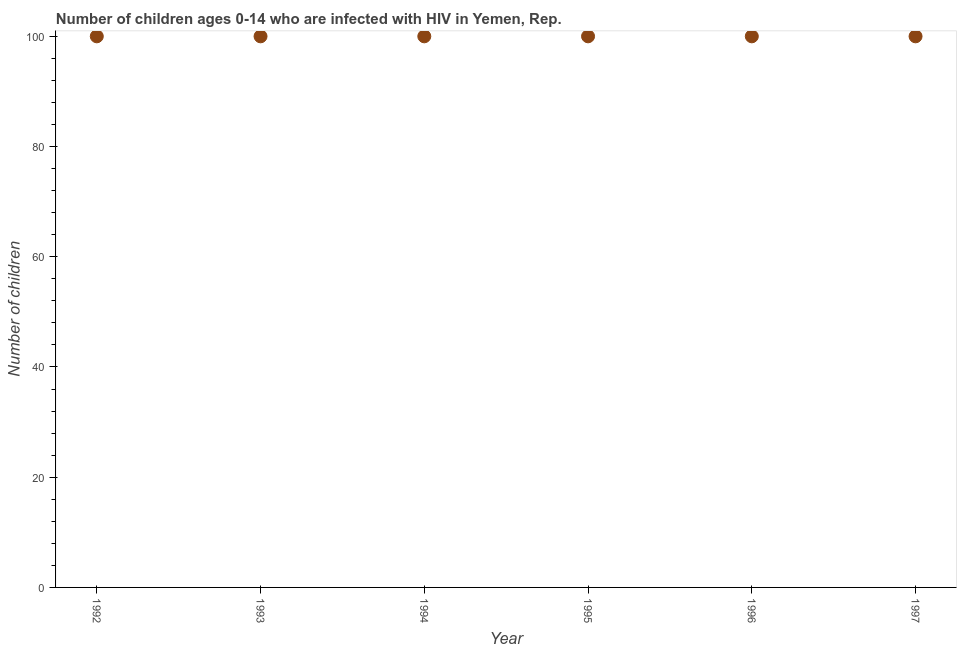What is the number of children living with hiv in 1996?
Your response must be concise. 100. Across all years, what is the maximum number of children living with hiv?
Make the answer very short. 100. Across all years, what is the minimum number of children living with hiv?
Provide a short and direct response. 100. In which year was the number of children living with hiv maximum?
Your response must be concise. 1992. In which year was the number of children living with hiv minimum?
Your answer should be compact. 1992. What is the sum of the number of children living with hiv?
Your answer should be very brief. 600. What is the average number of children living with hiv per year?
Provide a succinct answer. 100. In how many years, is the number of children living with hiv greater than 28 ?
Your answer should be very brief. 6. What is the difference between the highest and the second highest number of children living with hiv?
Your answer should be compact. 0. What is the difference between the highest and the lowest number of children living with hiv?
Your answer should be compact. 0. In how many years, is the number of children living with hiv greater than the average number of children living with hiv taken over all years?
Your response must be concise. 0. How many years are there in the graph?
Your answer should be compact. 6. What is the difference between two consecutive major ticks on the Y-axis?
Make the answer very short. 20. What is the title of the graph?
Ensure brevity in your answer.  Number of children ages 0-14 who are infected with HIV in Yemen, Rep. What is the label or title of the X-axis?
Ensure brevity in your answer.  Year. What is the label or title of the Y-axis?
Offer a terse response. Number of children. What is the Number of children in 1994?
Give a very brief answer. 100. What is the difference between the Number of children in 1992 and 1994?
Your answer should be compact. 0. What is the difference between the Number of children in 1992 and 1996?
Ensure brevity in your answer.  0. What is the difference between the Number of children in 1993 and 1994?
Keep it short and to the point. 0. What is the difference between the Number of children in 1993 and 1997?
Ensure brevity in your answer.  0. What is the difference between the Number of children in 1994 and 1996?
Offer a terse response. 0. What is the ratio of the Number of children in 1992 to that in 1993?
Your answer should be compact. 1. What is the ratio of the Number of children in 1992 to that in 1994?
Your answer should be very brief. 1. What is the ratio of the Number of children in 1992 to that in 1997?
Ensure brevity in your answer.  1. What is the ratio of the Number of children in 1993 to that in 1994?
Make the answer very short. 1. What is the ratio of the Number of children in 1994 to that in 1995?
Keep it short and to the point. 1. What is the ratio of the Number of children in 1994 to that in 1996?
Give a very brief answer. 1. What is the ratio of the Number of children in 1994 to that in 1997?
Your response must be concise. 1. What is the ratio of the Number of children in 1995 to that in 1996?
Ensure brevity in your answer.  1. What is the ratio of the Number of children in 1995 to that in 1997?
Provide a succinct answer. 1. What is the ratio of the Number of children in 1996 to that in 1997?
Offer a terse response. 1. 